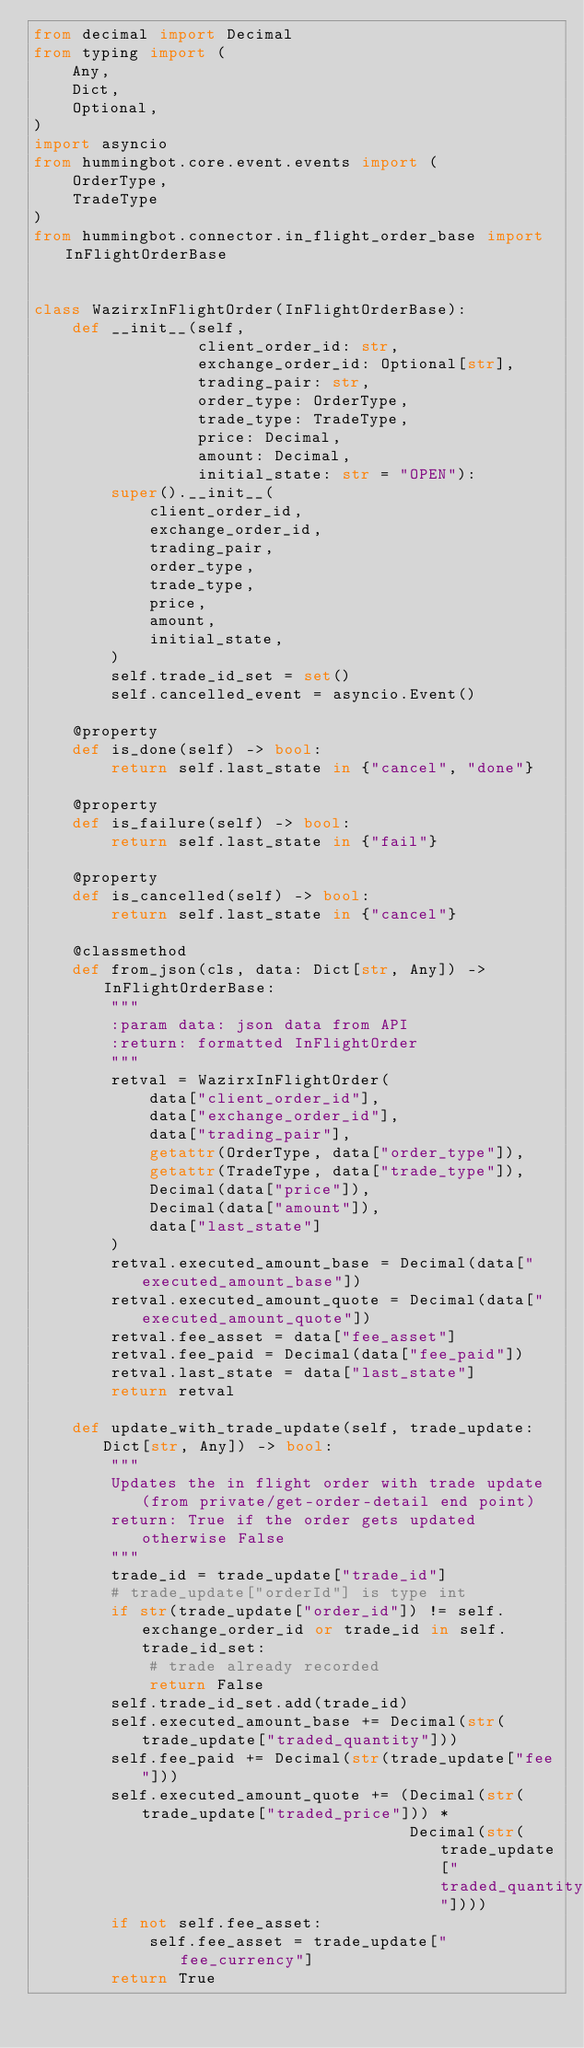<code> <loc_0><loc_0><loc_500><loc_500><_Python_>from decimal import Decimal
from typing import (
    Any,
    Dict,
    Optional,
)
import asyncio
from hummingbot.core.event.events import (
    OrderType,
    TradeType
)
from hummingbot.connector.in_flight_order_base import InFlightOrderBase


class WazirxInFlightOrder(InFlightOrderBase):
    def __init__(self,
                 client_order_id: str,
                 exchange_order_id: Optional[str],
                 trading_pair: str,
                 order_type: OrderType,
                 trade_type: TradeType,
                 price: Decimal,
                 amount: Decimal,
                 initial_state: str = "OPEN"):
        super().__init__(
            client_order_id,
            exchange_order_id,
            trading_pair,
            order_type,
            trade_type,
            price,
            amount,
            initial_state,
        )
        self.trade_id_set = set()
        self.cancelled_event = asyncio.Event()

    @property
    def is_done(self) -> bool:
        return self.last_state in {"cancel", "done"}

    @property
    def is_failure(self) -> bool:
        return self.last_state in {"fail"}

    @property
    def is_cancelled(self) -> bool:
        return self.last_state in {"cancel"}

    @classmethod
    def from_json(cls, data: Dict[str, Any]) -> InFlightOrderBase:
        """
        :param data: json data from API
        :return: formatted InFlightOrder
        """
        retval = WazirxInFlightOrder(
            data["client_order_id"],
            data["exchange_order_id"],
            data["trading_pair"],
            getattr(OrderType, data["order_type"]),
            getattr(TradeType, data["trade_type"]),
            Decimal(data["price"]),
            Decimal(data["amount"]),
            data["last_state"]
        )
        retval.executed_amount_base = Decimal(data["executed_amount_base"])
        retval.executed_amount_quote = Decimal(data["executed_amount_quote"])
        retval.fee_asset = data["fee_asset"]
        retval.fee_paid = Decimal(data["fee_paid"])
        retval.last_state = data["last_state"]
        return retval

    def update_with_trade_update(self, trade_update: Dict[str, Any]) -> bool:
        """
        Updates the in flight order with trade update (from private/get-order-detail end point)
        return: True if the order gets updated otherwise False
        """
        trade_id = trade_update["trade_id"]
        # trade_update["orderId"] is type int
        if str(trade_update["order_id"]) != self.exchange_order_id or trade_id in self.trade_id_set:
            # trade already recorded
            return False
        self.trade_id_set.add(trade_id)
        self.executed_amount_base += Decimal(str(trade_update["traded_quantity"]))
        self.fee_paid += Decimal(str(trade_update["fee"]))
        self.executed_amount_quote += (Decimal(str(trade_update["traded_price"])) *
                                       Decimal(str(trade_update["traded_quantity"])))
        if not self.fee_asset:
            self.fee_asset = trade_update["fee_currency"]
        return True
</code> 